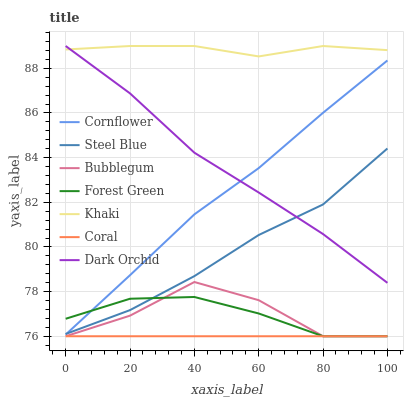Does Coral have the minimum area under the curve?
Answer yes or no. Yes. Does Khaki have the maximum area under the curve?
Answer yes or no. Yes. Does Khaki have the minimum area under the curve?
Answer yes or no. No. Does Coral have the maximum area under the curve?
Answer yes or no. No. Is Coral the smoothest?
Answer yes or no. Yes. Is Bubblegum the roughest?
Answer yes or no. Yes. Is Khaki the smoothest?
Answer yes or no. No. Is Khaki the roughest?
Answer yes or no. No. Does Coral have the lowest value?
Answer yes or no. Yes. Does Khaki have the lowest value?
Answer yes or no. No. Does Dark Orchid have the highest value?
Answer yes or no. Yes. Does Coral have the highest value?
Answer yes or no. No. Is Coral less than Steel Blue?
Answer yes or no. Yes. Is Khaki greater than Steel Blue?
Answer yes or no. Yes. Does Dark Orchid intersect Cornflower?
Answer yes or no. Yes. Is Dark Orchid less than Cornflower?
Answer yes or no. No. Is Dark Orchid greater than Cornflower?
Answer yes or no. No. Does Coral intersect Steel Blue?
Answer yes or no. No. 